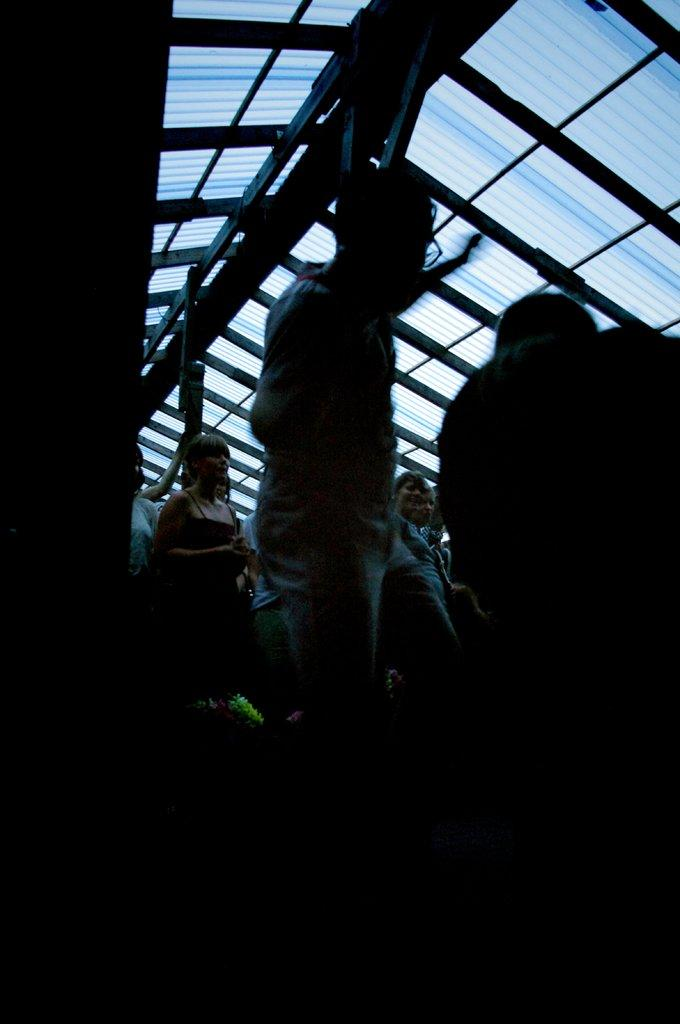What is the lighting condition at the bottom of the image? The bottom of the image is dark. What can be seen in the image besides the lighting condition? There are people standing in the image. What architectural feature is present on the glass roof? There are poles on the glass roof in the image. How does the fact twist and pull the glass roof in the image? There is no fact, twist, or pull present in the image. The image only shows people standing and poles on a glass roof with a dark bottom. 